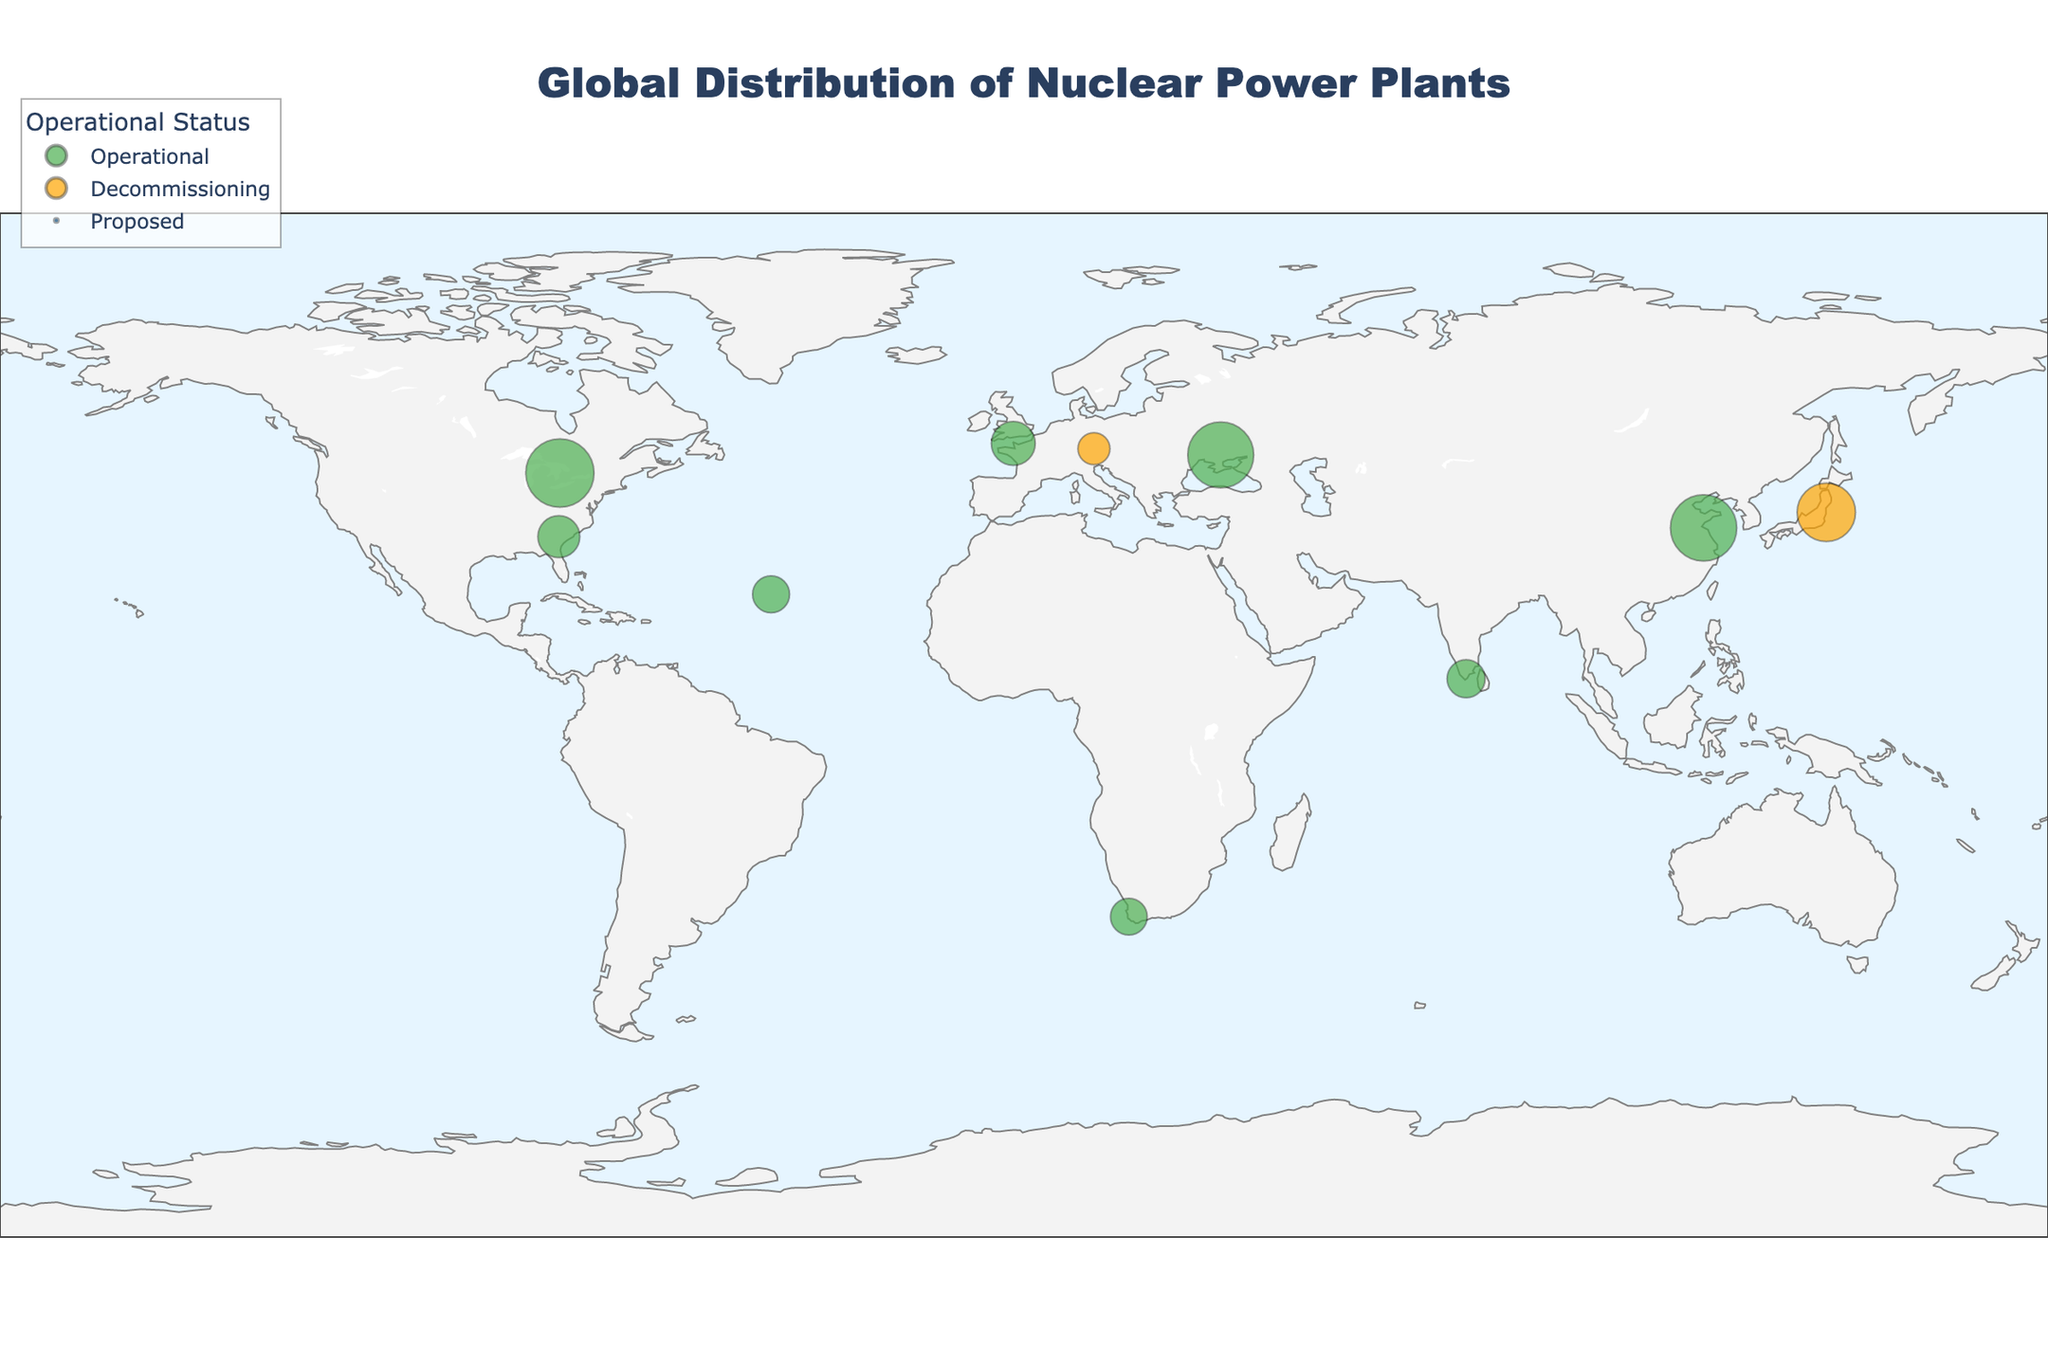What's the title of the plot? The title is displayed at the top center of the plot, usually in a larger and bold font. It summarises the overall topic of the figure. The title here is "Global Distribution of Nuclear Power Plants".
Answer: Global Distribution of Nuclear Power Plants How many nuclear power plants are operational in Europe? Count the number of data points labeled "Operational" specifically within the Europe region. Based on the figure, Flamanville and Zaporizhzhia are operational.
Answer: 2 Which nuclear power plant has the highest capacity in North America? Locate North America on the map and identify the plants there. Compare the capacity values shown for each. Bruce in Canada has a capacity of 6430 MW, which is the highest.
Answer: Bruce Which continent has the most nuclear power plants undergoing decommissioning? Look for labels with the status "Decommissioning" and count the instances per continent. Europe (Isar) and Asia (Fukushima Daiichi) both have one decommissioning plant each, so the answer would require selecting between Europe and Asia.
Answer: Europe and Asia What is the status of the nuclear power plant in Australia? Find the single data point in Oceania (Australia) and check its status label. The status of Jervis Bay is "Proposed."
Answer: Proposed Compare the capacities of the nuclear plants in France and Germany. Which one is greater and by how much? Check the capacities of Flamanville in France and Isar in Germany from the figure. Flamanville has 2660 MW, and Isar has 1410 MW. Subtract the lower capacity from the higher one. 2660 - 1410 = 1250 MW.
Answer: Flamanville is greater by 1250 MW Which country in Asia has the highest combined capacity of nuclear power plants? Identify all the nuclear power plants in Asia and sum their capacities: Tianwan (6070 MW), Fukushima Daiichi (4700 MW), and Kudankulam (2000 MW). China has the Tianwan plant which has the highest capacity, and it's greater than the capacities of Japan and India combined.
Answer: China Between the operational plants in North America and South America, which has a higher average capacity? Average the capacities of operational plants in North America (Vogtle 2430 MW and Bruce 6430 MW) and South America (Angra 1884 MW) separately. North America: (2430 + 6430) / 2 = 4430 MW, South America: 1884 MW. North America has the higher average capacity.
Answer: North America What is the operational status of the nuclear power plant located at 8.1631, 77.7144? Find the data point matching this latitude and longitude in the figure. Kudankulam in India matches these coordinates and is operational.
Answer: Operational Which nuclear plant is closer to the equator, Angra in Brazil or Kudankulam in India? Compare the latitudes of both nuclear plants. The latitude closer to 0 indicates proximity to the equator. Angra has a latitude of 23.0078, and Kudankulam has a latitude of 8.1631. Thus, Kudankulam is closer.
Answer: Kudankulam 